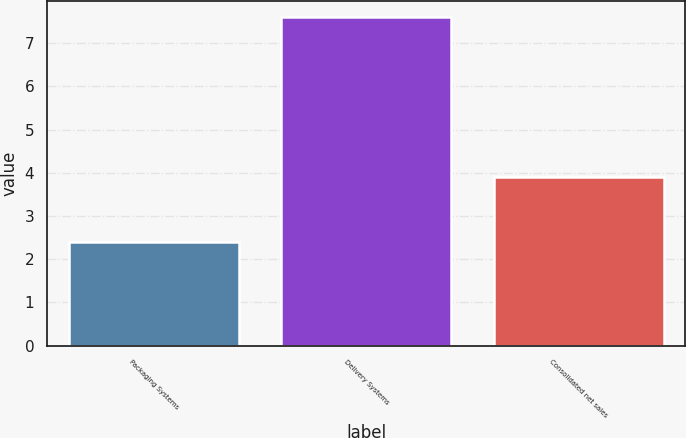<chart> <loc_0><loc_0><loc_500><loc_500><bar_chart><fcel>Packaging Systems<fcel>Delivery Systems<fcel>Consolidated net sales<nl><fcel>2.4<fcel>7.6<fcel>3.9<nl></chart> 